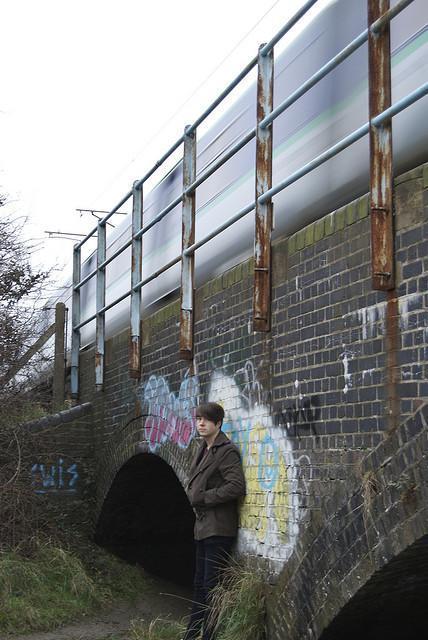How many of the train cars are yellow and red?
Give a very brief answer. 0. 